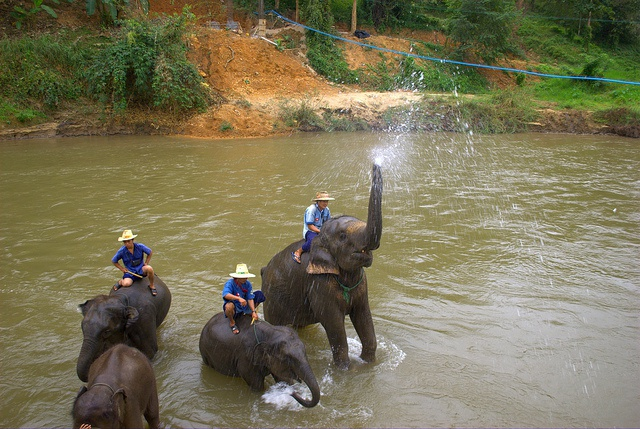Describe the objects in this image and their specific colors. I can see elephant in maroon, black, and gray tones, elephant in maroon, black, and gray tones, elephant in maroon, black, and gray tones, elephant in maroon, black, and gray tones, and people in maroon, navy, black, and gray tones in this image. 